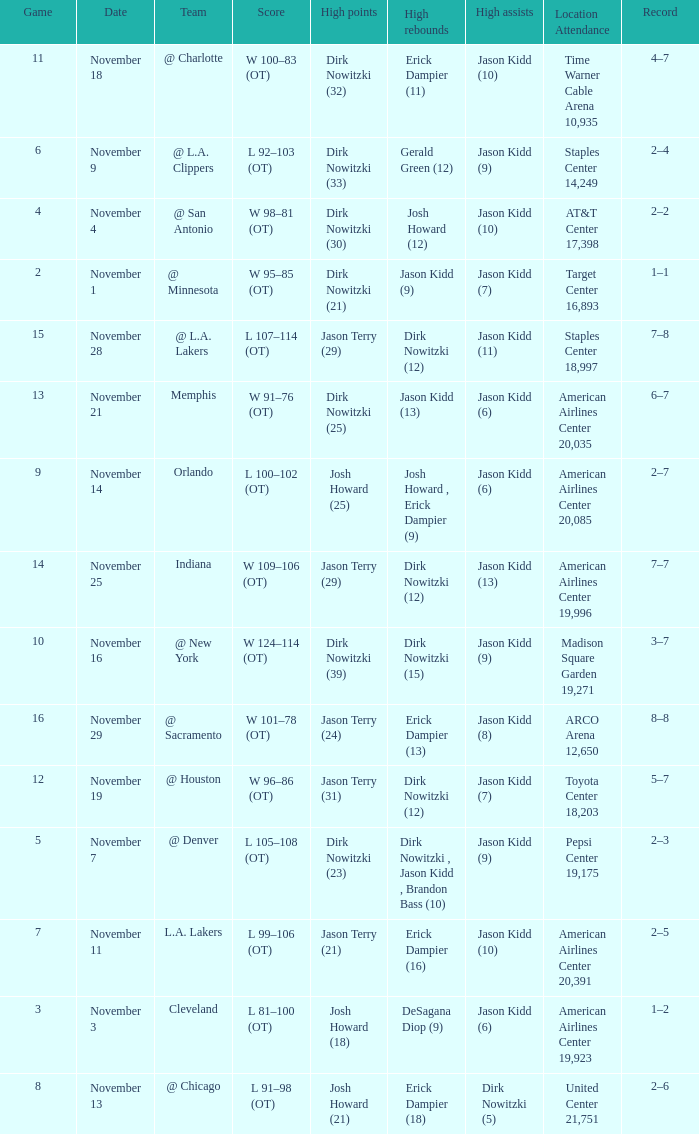What is High Rebounds, when High Assists is "Jason Kidd (13)"? Dirk Nowitzki (12). 